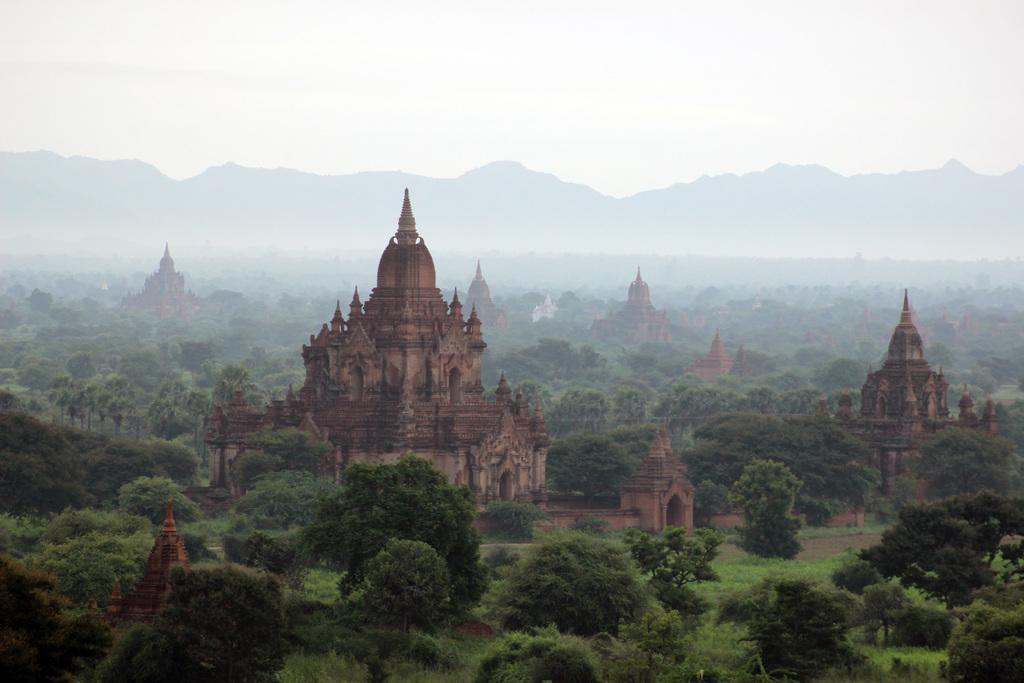What type of structures can be seen in the image? There are architectures in the image. What type of vegetation is present in the image? There are trees and plants in the image. What can be seen in the background of the image? Mountains and the sky are visible in the background of the image. How does the lumber help with the digestion of the dog in the image? There is no dog or lumber present in the image, so it is not possible to answer that question. 